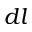Convert formula to latex. <formula><loc_0><loc_0><loc_500><loc_500>d l</formula> 